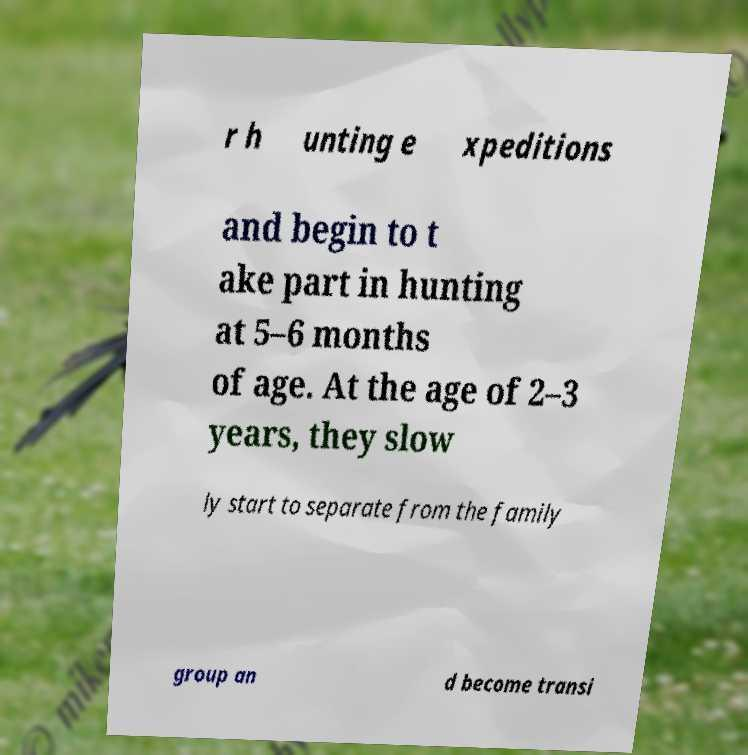Could you assist in decoding the text presented in this image and type it out clearly? r h unting e xpeditions and begin to t ake part in hunting at 5–6 months of age. At the age of 2–3 years, they slow ly start to separate from the family group an d become transi 